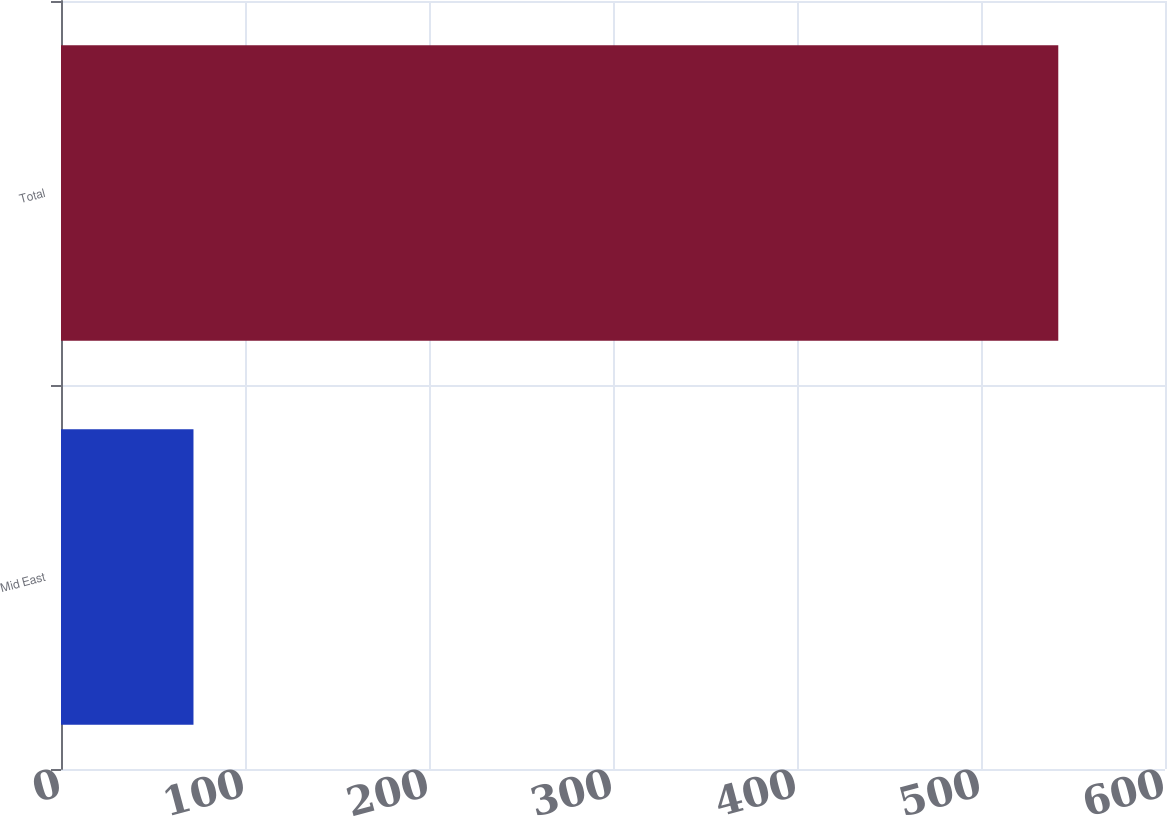Convert chart to OTSL. <chart><loc_0><loc_0><loc_500><loc_500><bar_chart><fcel>Mid East<fcel>Total<nl><fcel>72<fcel>542<nl></chart> 